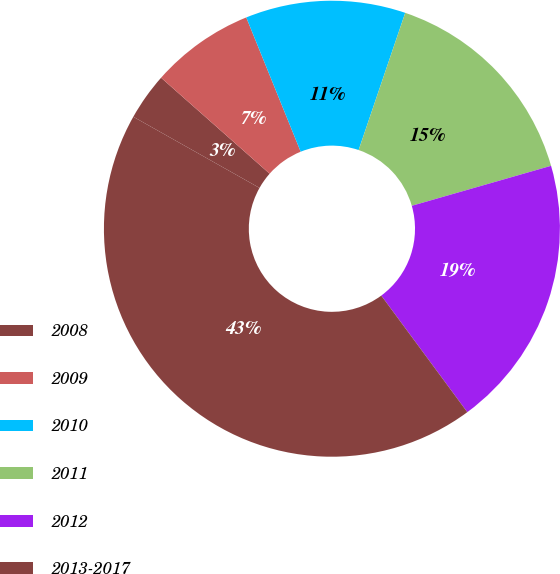Convert chart to OTSL. <chart><loc_0><loc_0><loc_500><loc_500><pie_chart><fcel>2008<fcel>2009<fcel>2010<fcel>2011<fcel>2012<fcel>2013-2017<nl><fcel>3.35%<fcel>7.35%<fcel>11.34%<fcel>15.34%<fcel>19.33%<fcel>43.29%<nl></chart> 